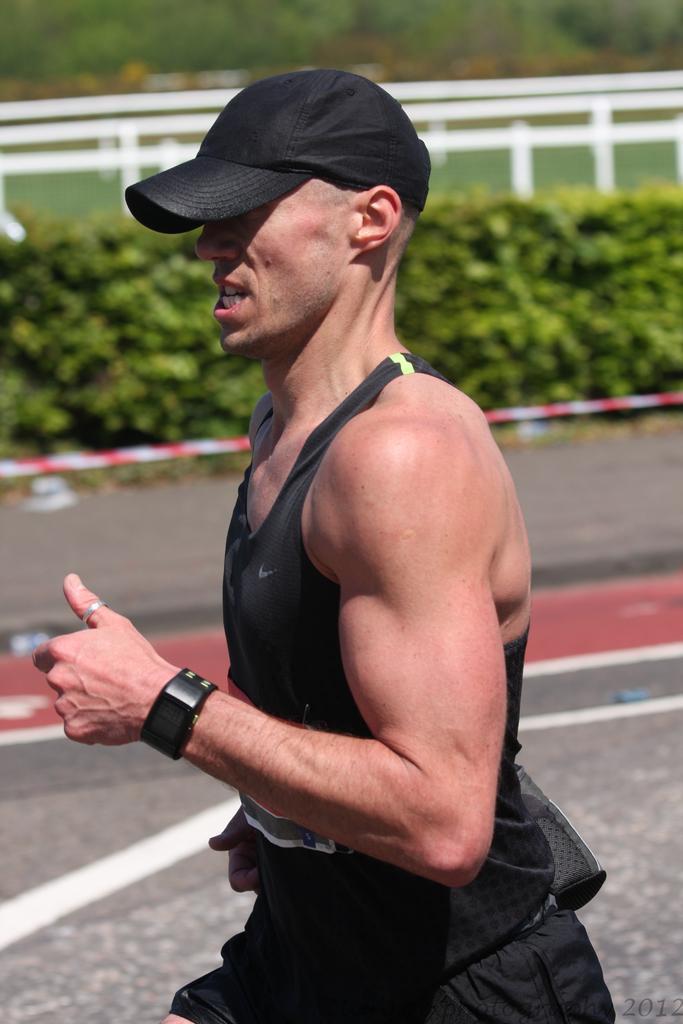Describe this image in one or two sentences. In this picture I can see a person wearing cap and running, side there are some plants. 